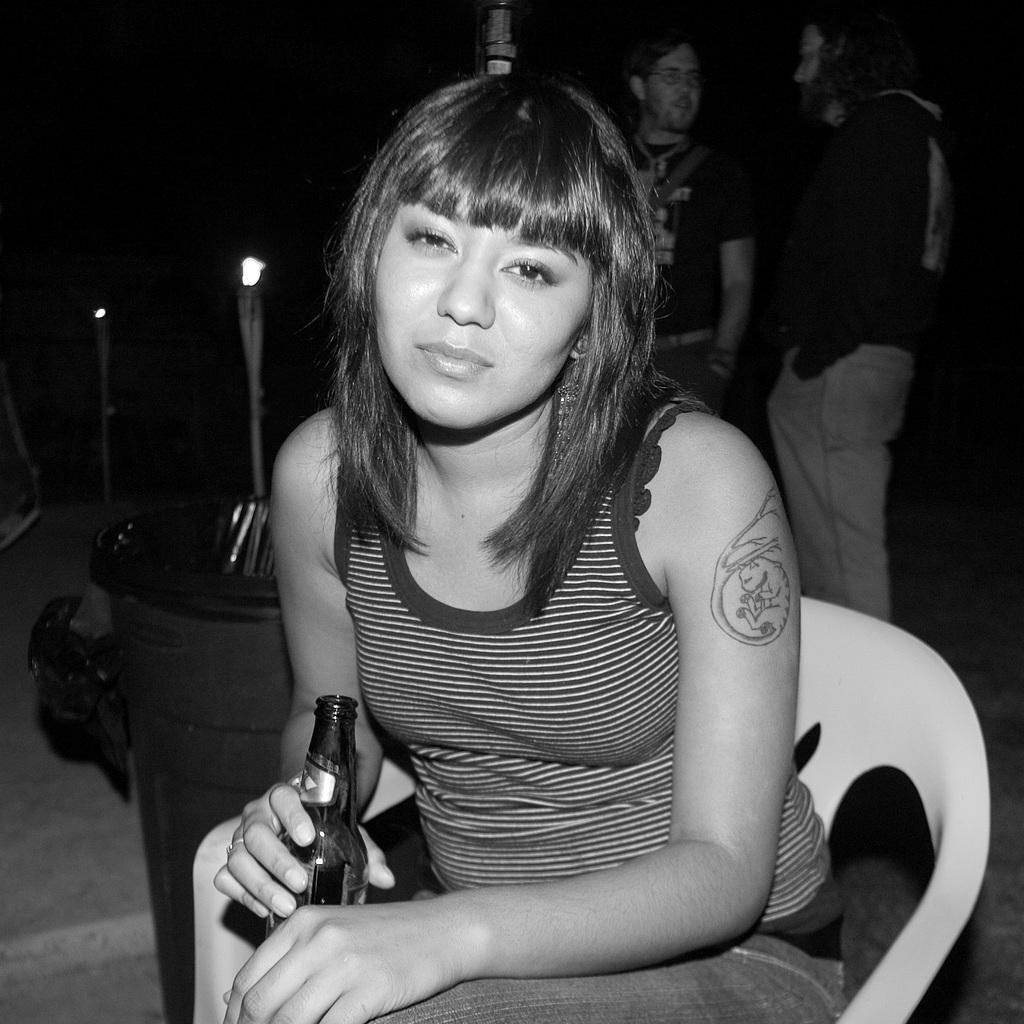In one or two sentences, can you explain what this image depicts? In the foreground of the image, there is a lady sitting on the chair and holding a liquor bottle in her hand. In the background of the image right, there are two person standing and talking. The background is dark in color. This image is taken inside a bar. 